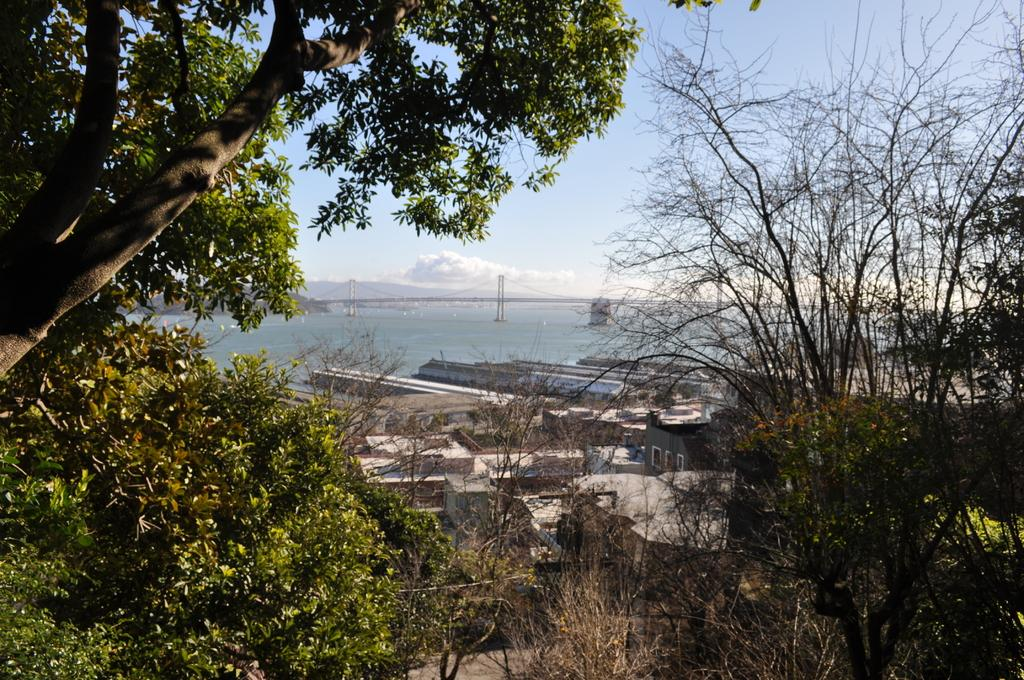What type of vegetation is visible in the front of the image? There are trees in the front of the image. What type of structures can be seen in the center of the image? There are buildings in the center of the image. What natural feature is visible in the background of the image? There is an ocean in the background of the image. How would you describe the sky in the image? The sky is cloudy in the image. How many pears are hanging from the trees in the image? There are no pears visible in the image; it features trees, buildings, and an ocean. What type of chairs can be seen in the image? There are no chairs present in the image. 